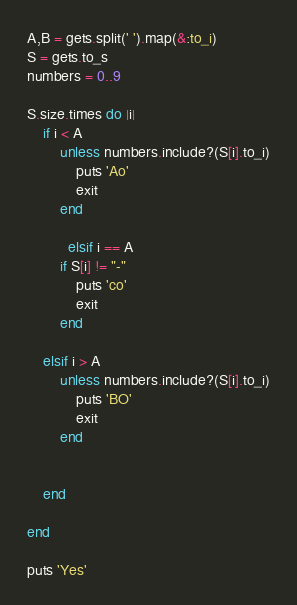<code> <loc_0><loc_0><loc_500><loc_500><_Ruby_>A,B = gets.split(' ').map(&:to_i)
S = gets.to_s
numbers = 0..9

S.size.times do |i|
	if i < A
		unless numbers.include?(S[i].to_i)
			puts 'Ao'
			exit
		end
      
          elsif i == A
		if S[i] != "-"
			puts 'co'
			exit
		end
      
    elsif i > A
		unless numbers.include?(S[i].to_i)
			puts 'BO'
			exit
		end


	end

end

puts 'Yes'
</code> 